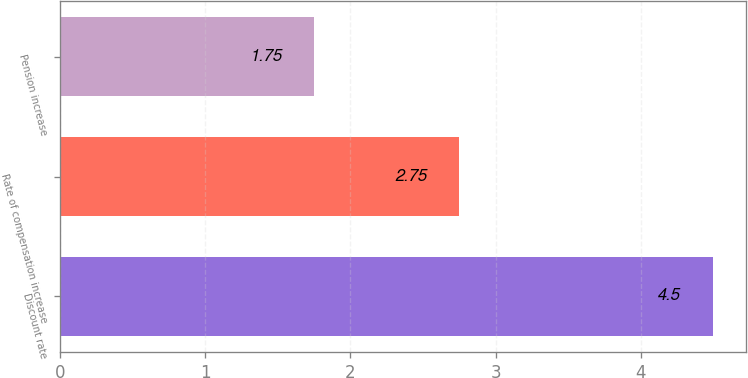<chart> <loc_0><loc_0><loc_500><loc_500><bar_chart><fcel>Discount rate<fcel>Rate of compensation increase<fcel>Pension increase<nl><fcel>4.5<fcel>2.75<fcel>1.75<nl></chart> 